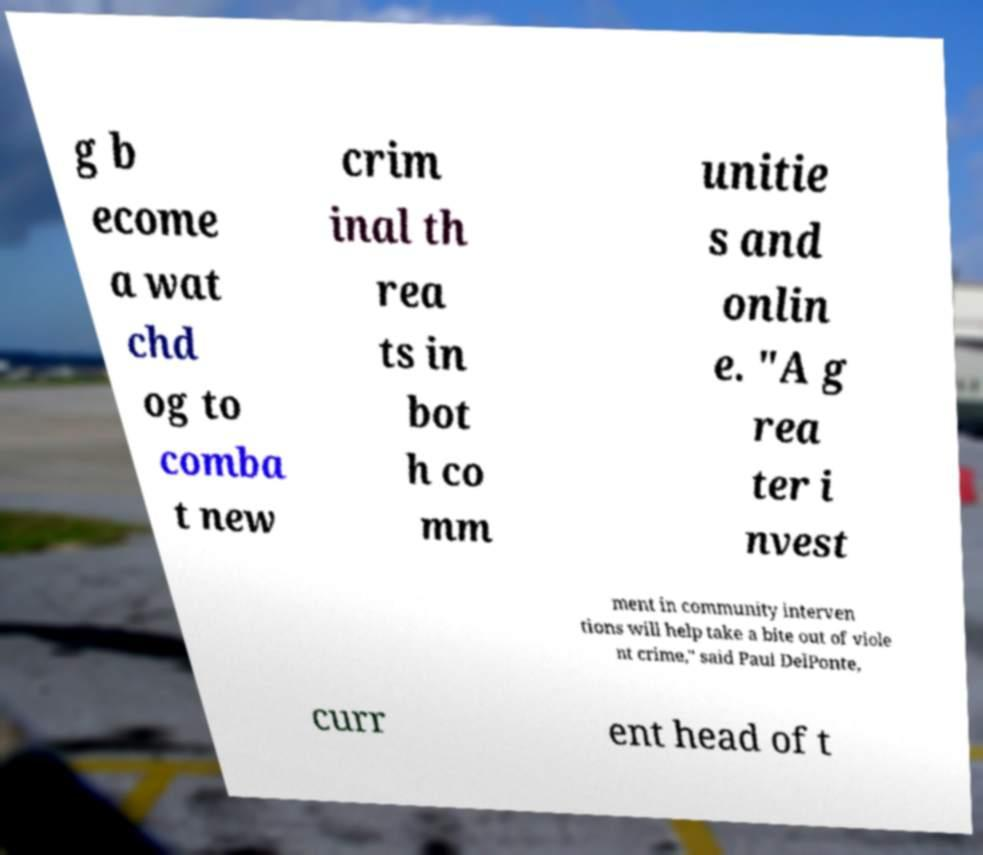Could you assist in decoding the text presented in this image and type it out clearly? g b ecome a wat chd og to comba t new crim inal th rea ts in bot h co mm unitie s and onlin e. "A g rea ter i nvest ment in community interven tions will help take a bite out of viole nt crime," said Paul DelPonte, curr ent head of t 